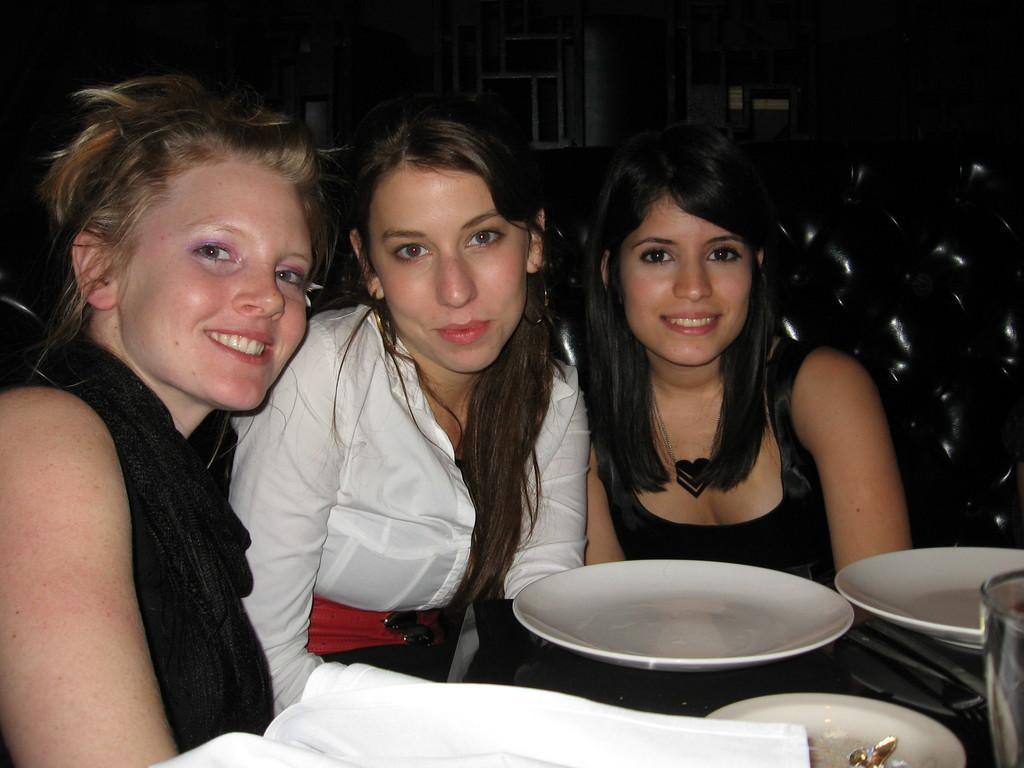How would you summarize this image in a sentence or two? Left a beautiful girl is sitting on the chair she wears a black color dress. She is smiling too in the middle a girl sitting she is wearing a good white colour dress she is so hot in the right a girl is sitting she wears black color dress there are plates on this dining table. 